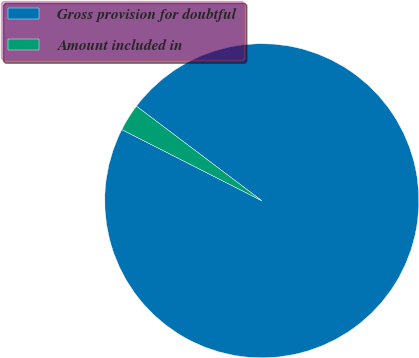Convert chart. <chart><loc_0><loc_0><loc_500><loc_500><pie_chart><fcel>Gross provision for doubtful<fcel>Amount included in<nl><fcel>97.2%<fcel>2.8%<nl></chart> 